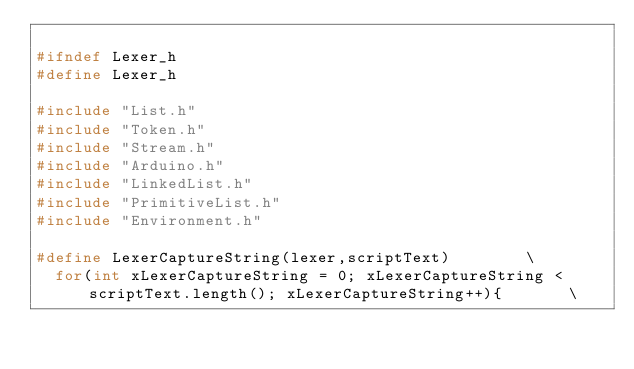<code> <loc_0><loc_0><loc_500><loc_500><_C_>
#ifndef Lexer_h
#define Lexer_h

#include "List.h"
#include "Token.h"
#include "Stream.h"
#include "Arduino.h"
#include "LinkedList.h"
#include "PrimitiveList.h"
#include "Environment.h"

#define LexerCaptureString(lexer,scriptText)		\
  for(int xLexerCaptureString = 0; xLexerCaptureString < scriptText.length(); xLexerCaptureString++){		\</code> 